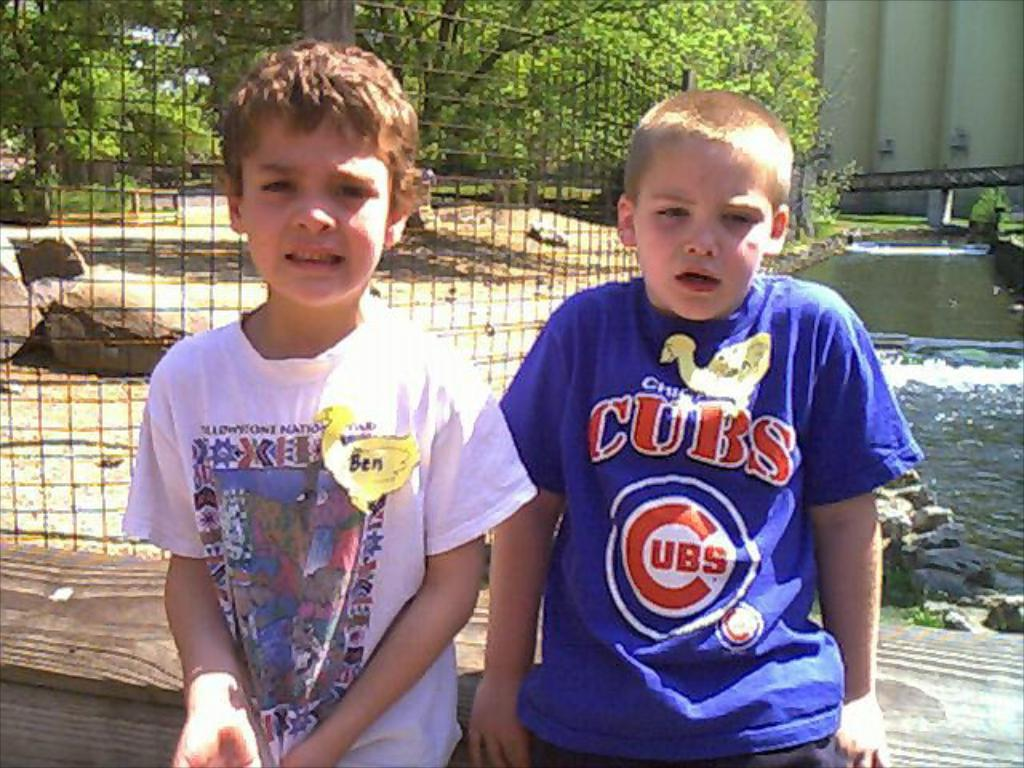Provide a one-sentence caption for the provided image. A little boy in a blue Chicago Cubs tshirt sits next to a boy named Ben. 